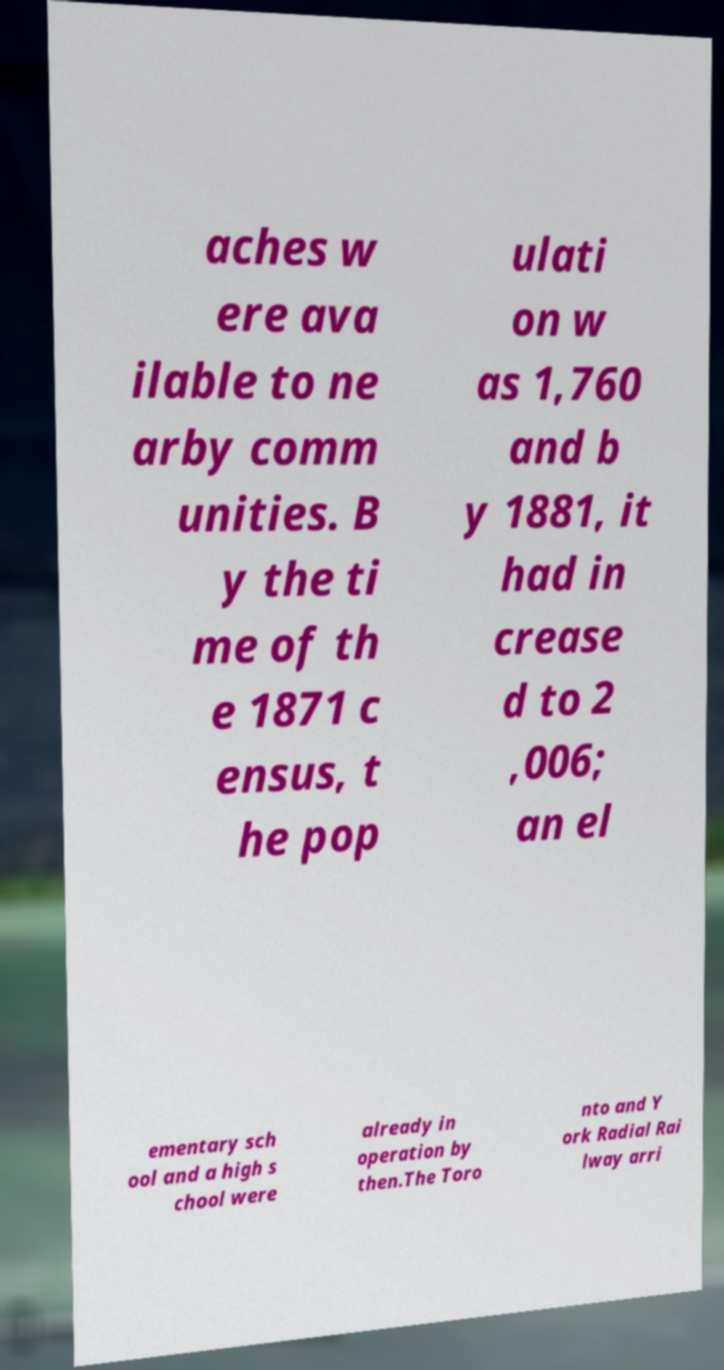There's text embedded in this image that I need extracted. Can you transcribe it verbatim? aches w ere ava ilable to ne arby comm unities. B y the ti me of th e 1871 c ensus, t he pop ulati on w as 1,760 and b y 1881, it had in crease d to 2 ,006; an el ementary sch ool and a high s chool were already in operation by then.The Toro nto and Y ork Radial Rai lway arri 